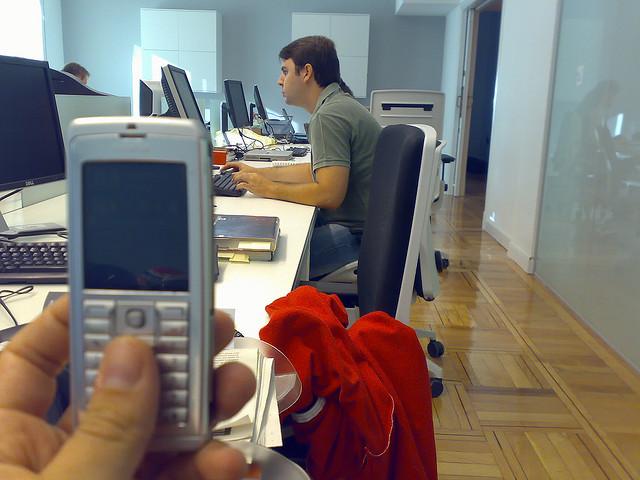Is this a photo of a call center?
Give a very brief answer. Yes. Why is there a red/orange jacket not being worn?
Answer briefly. Inside. How many computer monitors can be seen?
Concise answer only. 4. 